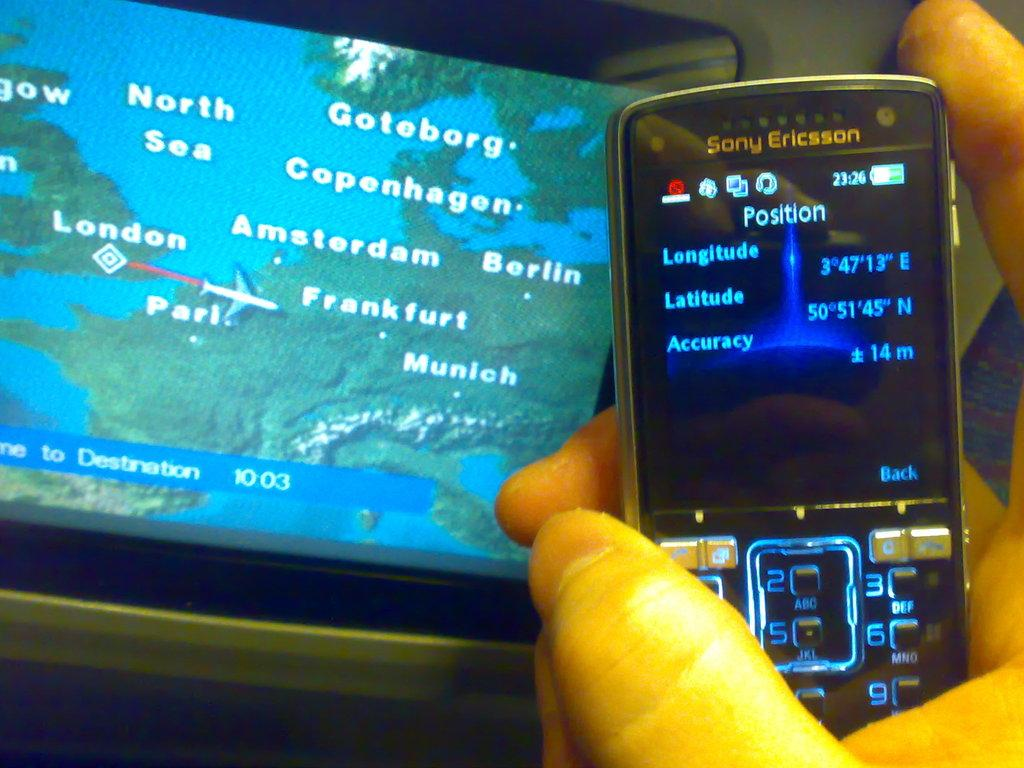<image>
Share a concise interpretation of the image provided. A Sony Ericsson phone shows the Longitude and Latitude. 